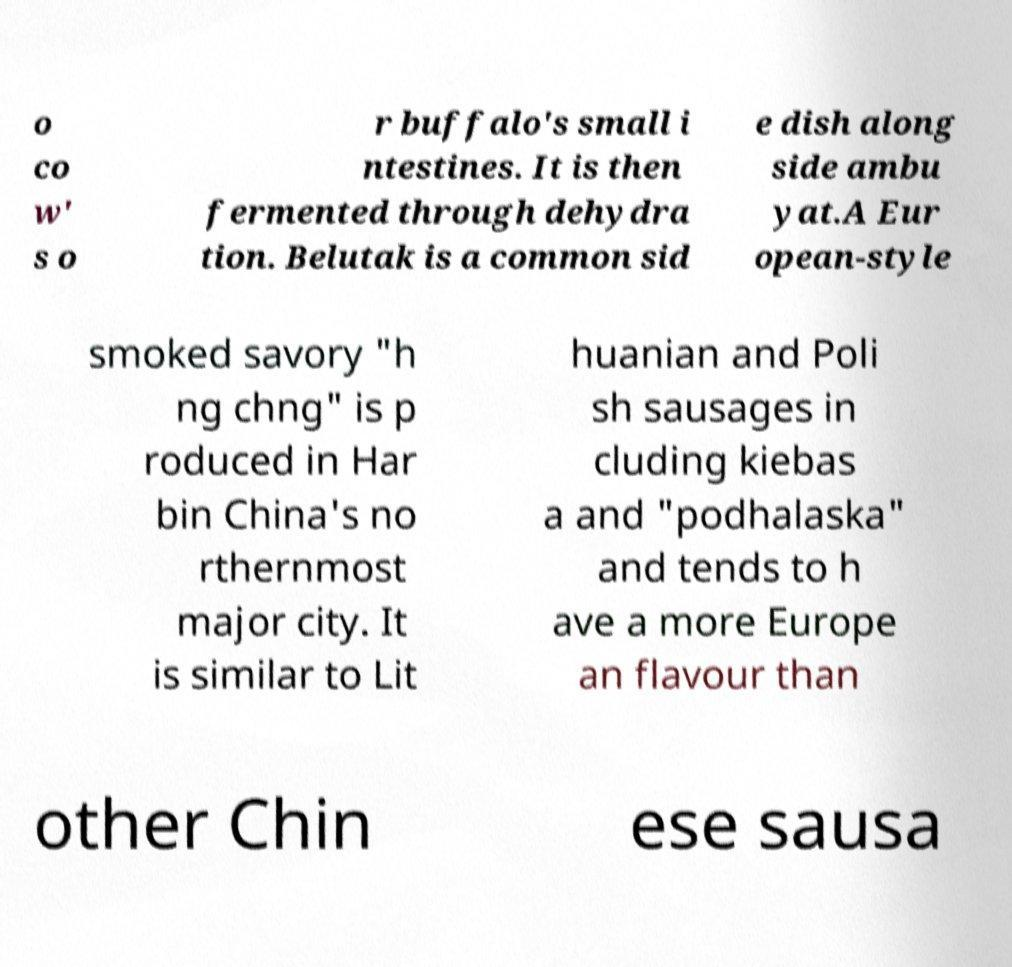Can you accurately transcribe the text from the provided image for me? o co w' s o r buffalo's small i ntestines. It is then fermented through dehydra tion. Belutak is a common sid e dish along side ambu yat.A Eur opean-style smoked savory "h ng chng" is p roduced in Har bin China's no rthernmost major city. It is similar to Lit huanian and Poli sh sausages in cluding kiebas a and "podhalaska" and tends to h ave a more Europe an flavour than other Chin ese sausa 